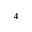Convert formula to latex. <formula><loc_0><loc_0><loc_500><loc_500>^ { 4 }</formula> 